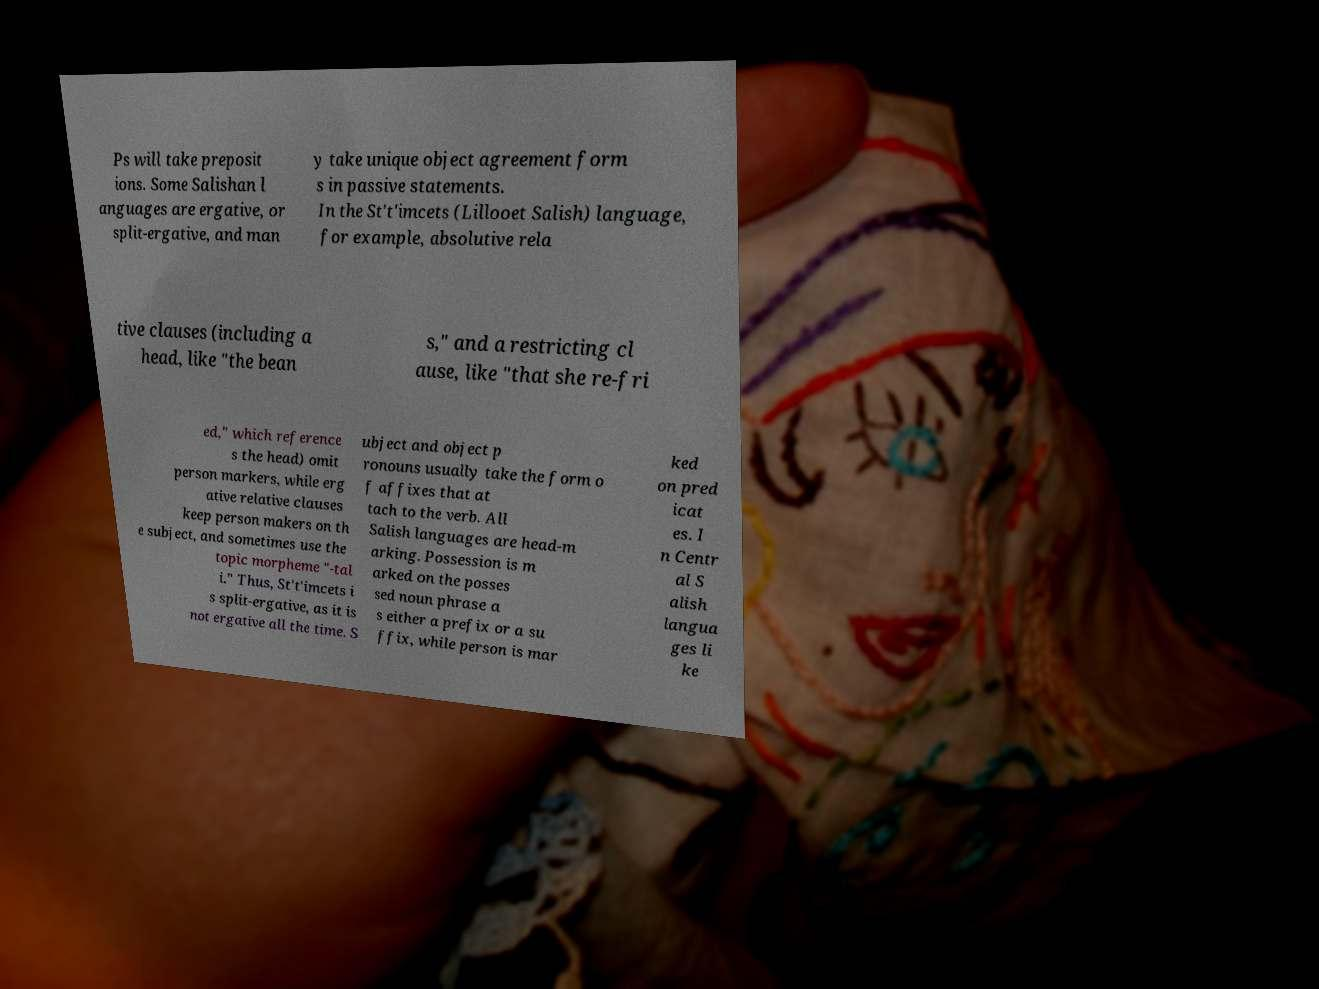Please read and relay the text visible in this image. What does it say? Ps will take preposit ions. Some Salishan l anguages are ergative, or split-ergative, and man y take unique object agreement form s in passive statements. In the St't'imcets (Lillooet Salish) language, for example, absolutive rela tive clauses (including a head, like "the bean s," and a restricting cl ause, like "that she re-fri ed," which reference s the head) omit person markers, while erg ative relative clauses keep person makers on th e subject, and sometimes use the topic morpheme "-tal i." Thus, St't'imcets i s split-ergative, as it is not ergative all the time. S ubject and object p ronouns usually take the form o f affixes that at tach to the verb. All Salish languages are head-m arking. Possession is m arked on the posses sed noun phrase a s either a prefix or a su ffix, while person is mar ked on pred icat es. I n Centr al S alish langua ges li ke 